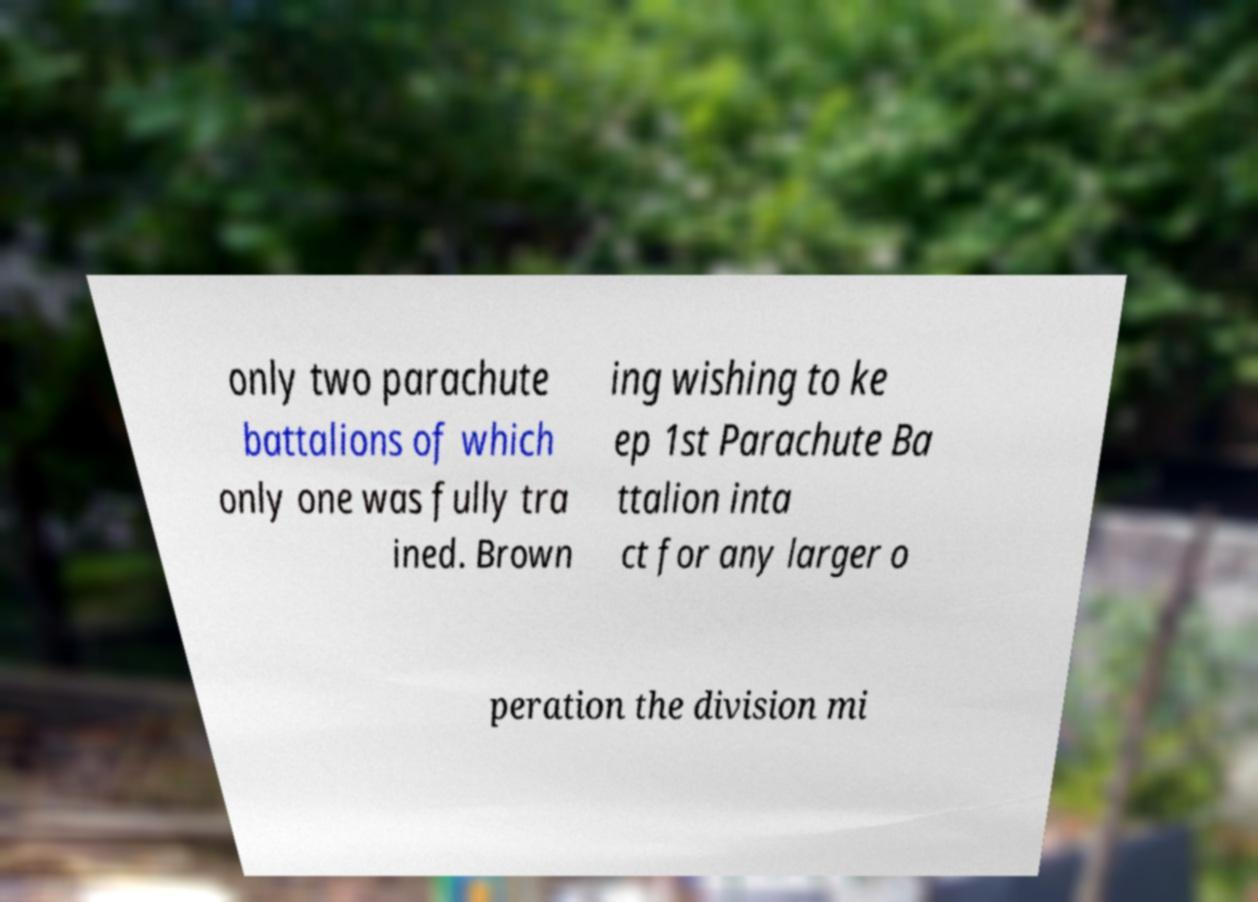There's text embedded in this image that I need extracted. Can you transcribe it verbatim? only two parachute battalions of which only one was fully tra ined. Brown ing wishing to ke ep 1st Parachute Ba ttalion inta ct for any larger o peration the division mi 